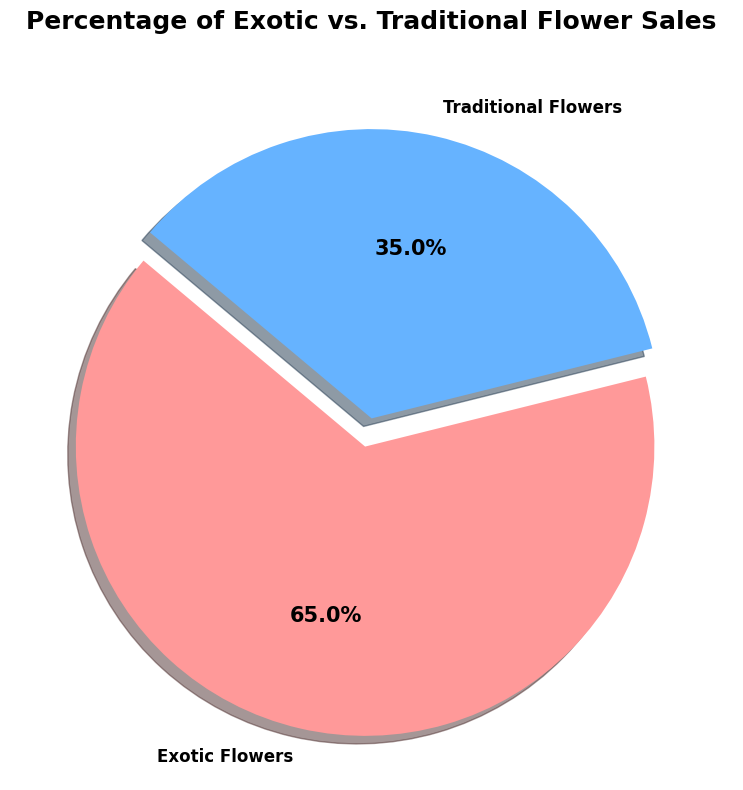What percentage of sales do Exotic Flowers account for? According to the pie chart, one section labeled "Exotic Flowers" shows the percentage of sales it accounts for.
Answer: 65% What is the difference in sales percentages between Exotic and Traditional Flowers? The pie chart shows Exotic Flowers at 65% and Traditional Flowers at 35%. Subtracting Traditional from Exotic: 65% - 35% = 30%.
Answer: 30% Are Exotic Flowers more popular than Traditional Flowers based on sales? Comparing the slices of the pie chart, Exotic Flowers have a larger portion at 65% compared to Traditional Flowers at 35%, indicating higher sales.
Answer: Yes What color represents the Exotic Flowers category in the pie chart? The pie chart has different colors for each category. Exotic Flowers are indicated in the redish colored section.
Answer: Redish If the total sales were 2000 units, how many units of Exotic Flowers were sold? Exotic Flowers make up 65% of total sales. To find the units: 2000 units * 0.65 = 1300 units.
Answer: 1300 units Which flower category accounts for the lesser percentage of sales? The pie chart has two categories, with Traditional Flowers at 35% and Exotic Flowers at 65%. The smaller percentage is for Traditional Flowers.
Answer: Traditional Flowers What portion of the pie has a shadow effect? The entire pie chart has a shadow effect applied to all slices, enhancing the visualization.
Answer: All If we add 10% of sales to Traditional Flowers, what will be the new sales percentage of Exotic Flowers? Initially, Traditional Flowers have 35% and Exotic Flowers 65%. Adding 10% to Traditional would make it 45%, and Exotic would decrease by 10% to keep the total 100%. So, 65% - 10% = 55%.
Answer: 55% 